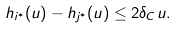<formula> <loc_0><loc_0><loc_500><loc_500>h _ { i ^ { * } } ( u ) - h _ { j ^ { * } } ( u ) \leq 2 \delta _ { C } u .</formula> 